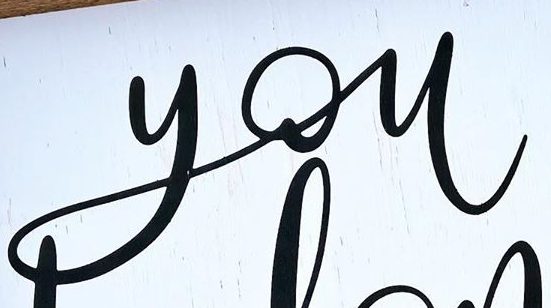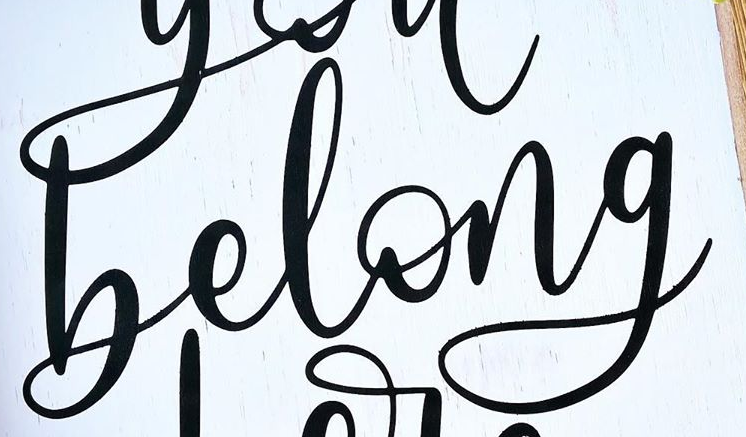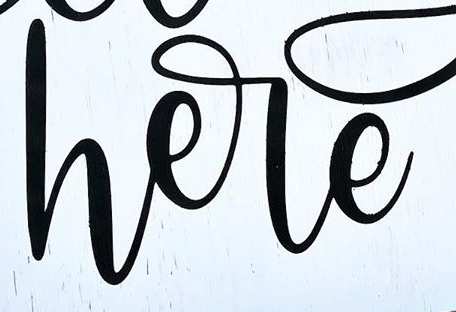Identify the words shown in these images in order, separated by a semicolon. you; belong; here 